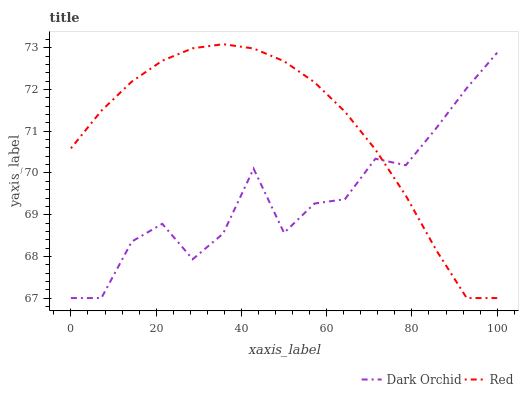Does Dark Orchid have the minimum area under the curve?
Answer yes or no. Yes. Does Red have the maximum area under the curve?
Answer yes or no. Yes. Does Dark Orchid have the maximum area under the curve?
Answer yes or no. No. Is Red the smoothest?
Answer yes or no. Yes. Is Dark Orchid the roughest?
Answer yes or no. Yes. Is Dark Orchid the smoothest?
Answer yes or no. No. Does Dark Orchid have the highest value?
Answer yes or no. No. 